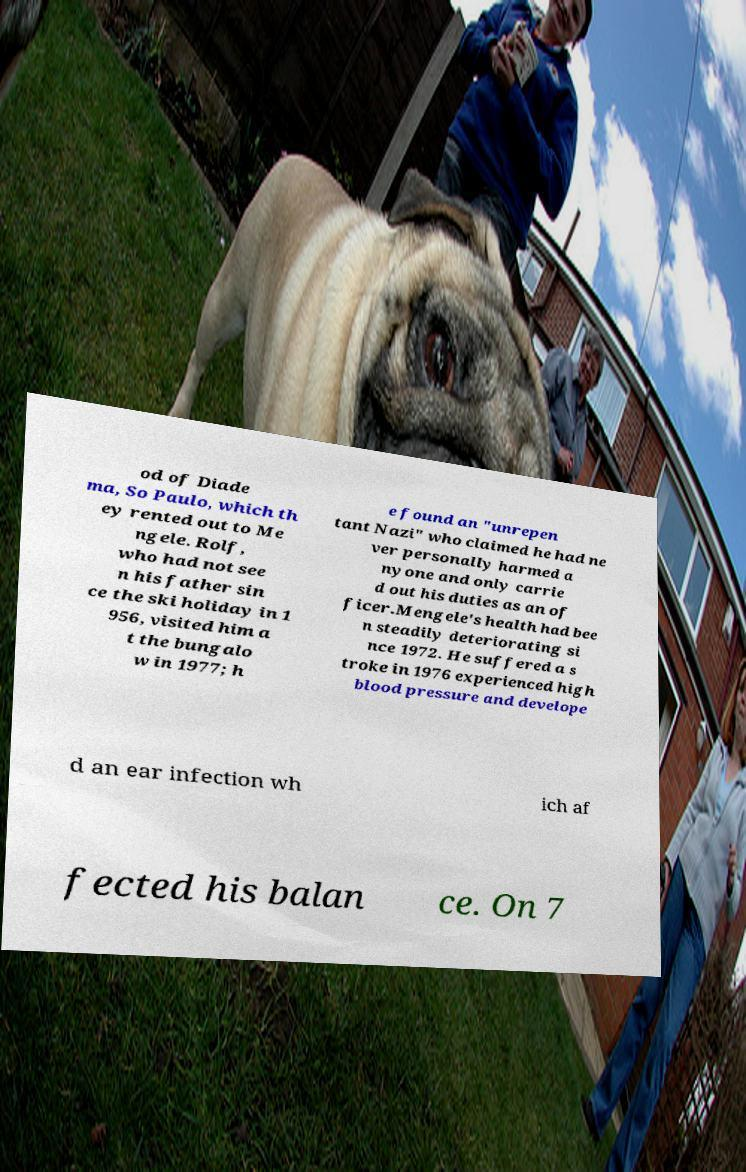Can you accurately transcribe the text from the provided image for me? od of Diade ma, So Paulo, which th ey rented out to Me ngele. Rolf, who had not see n his father sin ce the ski holiday in 1 956, visited him a t the bungalo w in 1977; h e found an "unrepen tant Nazi" who claimed he had ne ver personally harmed a nyone and only carrie d out his duties as an of ficer.Mengele's health had bee n steadily deteriorating si nce 1972. He suffered a s troke in 1976 experienced high blood pressure and develope d an ear infection wh ich af fected his balan ce. On 7 